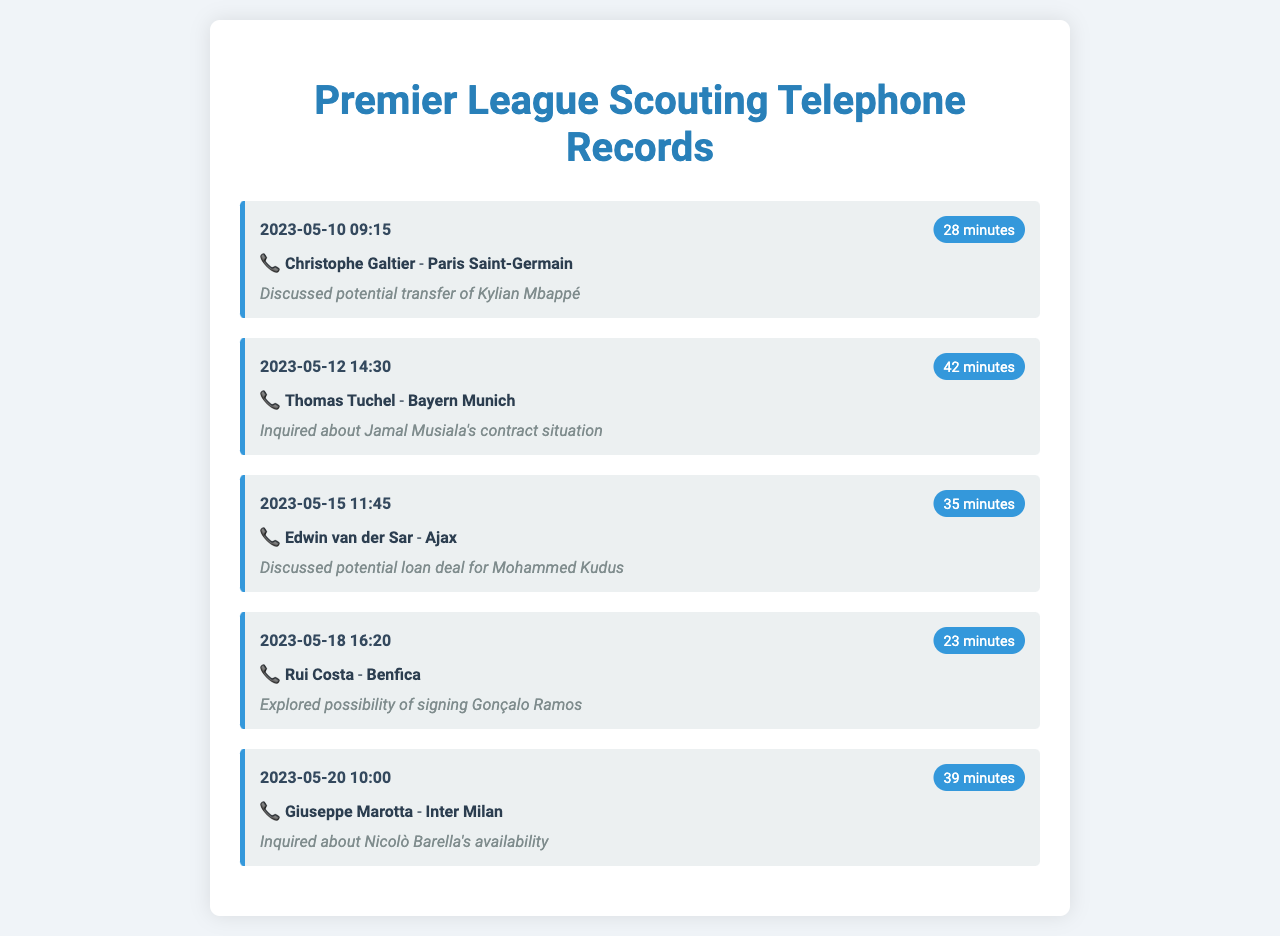What is the date of the call with Christophe Galtier? The call with Christophe Galtier occurred on May 10, 2023.
Answer: May 10, 2023 How long was the call with Thomas Tuchel? The call with Thomas Tuchel lasted for 42 minutes.
Answer: 42 minutes Which player was discussed during the call with Edwin van der Sar? The call with Edwin van der Sar was about Mohammed Kudus.
Answer: Mohammed Kudus What club does Rui Costa represent? Rui Costa is associated with Benfica.
Answer: Benfica Who inquired about Nicolò Barella's availability? Giuseppe Marotta inquired about Nicolò Barella's availability.
Answer: Giuseppe Marotta How many minutes long was the shortest call recorded? The shortest call recorded was 23 minutes long.
Answer: 23 minutes What is the primary purpose of these calls? The primary purpose of these calls is to scout potential players from overseas clubs.
Answer: To scout potential players Which call discussed a potential transfer? The call with Christophe Galtier discussed a potential transfer.
Answer: Christophe Galtier Which club is Jamal Musiala associated with? Jamal Musiala is associated with Bayern Munich.
Answer: Bayern Munich 